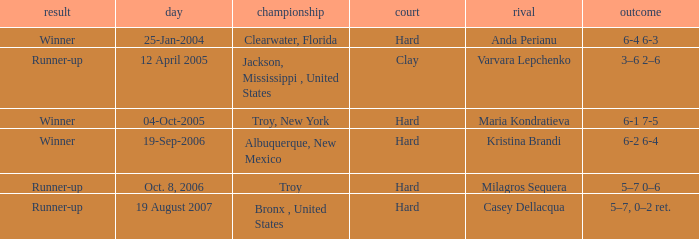Could you parse the entire table? {'header': ['result', 'day', 'championship', 'court', 'rival', 'outcome'], 'rows': [['Winner', '25-Jan-2004', 'Clearwater, Florida', 'Hard', 'Anda Perianu', '6-4 6-3'], ['Runner-up', '12 April 2005', 'Jackson, Mississippi , United States', 'Clay', 'Varvara Lepchenko', '3–6 2–6'], ['Winner', '04-Oct-2005', 'Troy, New York', 'Hard', 'Maria Kondratieva', '6-1 7-5'], ['Winner', '19-Sep-2006', 'Albuquerque, New Mexico', 'Hard', 'Kristina Brandi', '6-2 6-4'], ['Runner-up', 'Oct. 8, 2006', 'Troy', 'Hard', 'Milagros Sequera', '5–7 0–6'], ['Runner-up', '19 August 2007', 'Bronx , United States', 'Hard', 'Casey Dellacqua', '5–7, 0–2 ret.']]} What is the final score of the tournament played in Clearwater, Florida? 6-4 6-3. 